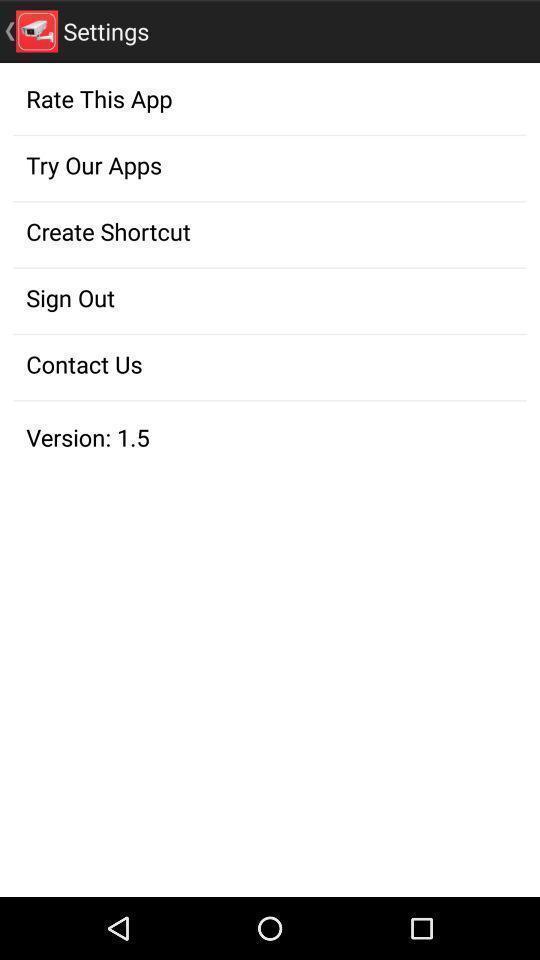What can you discern from this picture? Settings of a gaming app. 